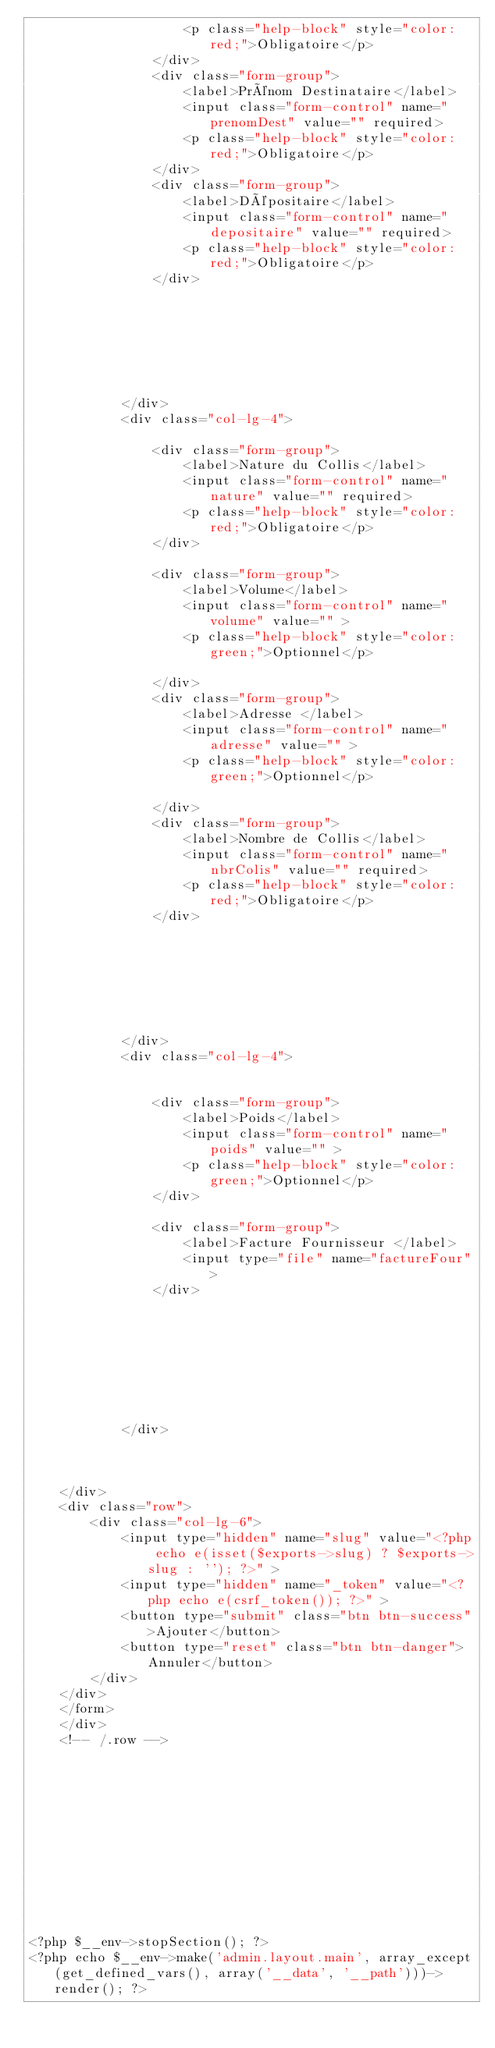<code> <loc_0><loc_0><loc_500><loc_500><_PHP_>                    <p class="help-block" style="color: red;">Obligatoire</p>
                </div>
                <div class="form-group">
                    <label>Prénom Destinataire</label>
                    <input class="form-control" name="prenomDest" value="" required>
                    <p class="help-block" style="color: red;">Obligatoire</p>
                </div>
                <div class="form-group">
                    <label>Dépositaire</label>
                    <input class="form-control" name="depositaire" value="" required>
                    <p class="help-block" style="color: red;">Obligatoire</p>
                </div>







            </div>
            <div class="col-lg-4">

                <div class="form-group">
                    <label>Nature du Collis</label>
                    <input class="form-control" name="nature" value="" required>
                    <p class="help-block" style="color: red;">Obligatoire</p>
                </div>

                <div class="form-group">
                    <label>Volume</label>
                    <input class="form-control" name="volume" value="" >
                    <p class="help-block" style="color: green;">Optionnel</p>

                </div>
                <div class="form-group">
                    <label>Adresse </label>
                    <input class="form-control" name="adresse" value="" >
                    <p class="help-block" style="color: green;">Optionnel</p>

                </div>
                <div class="form-group">
                    <label>Nombre de Collis</label>
                    <input class="form-control" name="nbrColis" value="" required>
                    <p class="help-block" style="color: red;">Obligatoire</p>
                </div>







            </div>
            <div class="col-lg-4">


                <div class="form-group">
                    <label>Poids</label>
                    <input class="form-control" name="poids" value="" >
                    <p class="help-block" style="color: green;">Optionnel</p>
                </div>

                <div class="form-group">
                    <label>Facture Fournisseur </label>
                    <input type="file" name="factureFour">
                </div>








            </div>



    </div>
    <div class="row">
        <div class="col-lg-6">
            <input type="hidden" name="slug" value="<?php echo e(isset($exports->slug) ? $exports->slug : ''); ?>" >
            <input type="hidden" name="_token" value="<?php echo e(csrf_token()); ?>" >
            <button type="submit" class="btn btn-success">Ajouter</button>
            <button type="reset" class="btn btn-danger">Annuler</button>
        </div>
    </div>
    </form>
    </div>
    <!-- /.row -->












<?php $__env->stopSection(); ?>
<?php echo $__env->make('admin.layout.main', array_except(get_defined_vars(), array('__data', '__path')))->render(); ?></code> 